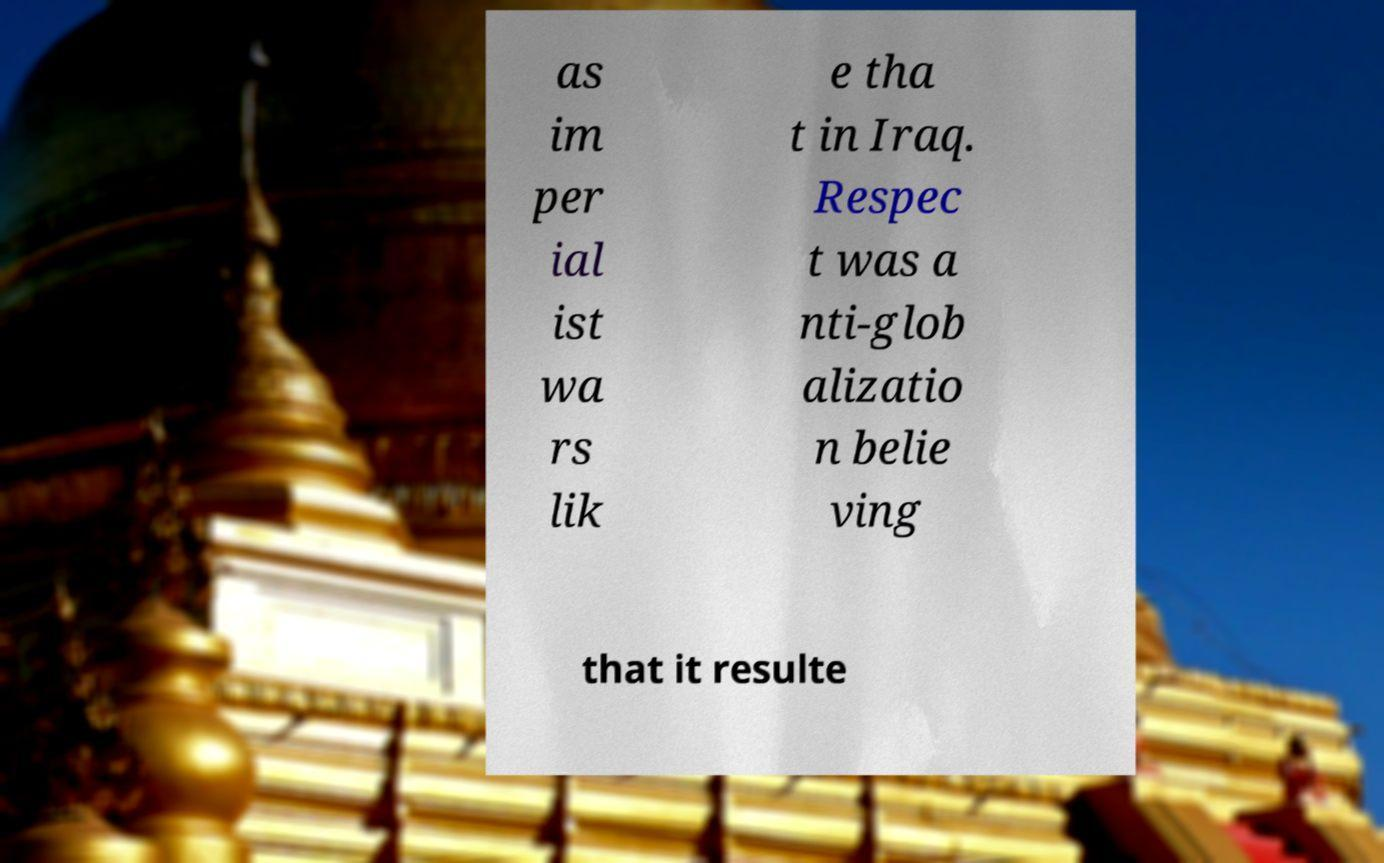Can you accurately transcribe the text from the provided image for me? as im per ial ist wa rs lik e tha t in Iraq. Respec t was a nti-glob alizatio n belie ving that it resulte 